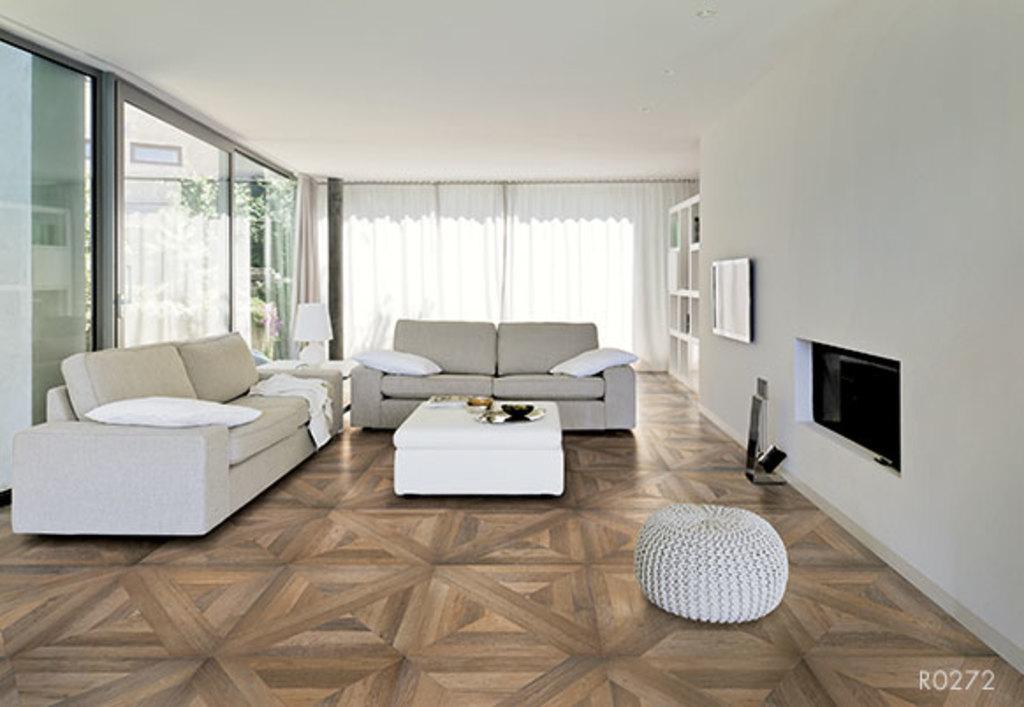Could you give a brief overview of what you see in this image? The image is taken in the room. In the center of the image there is a sofa and there is a stand placed before it. On the right there is a tv attached to the wall. on the left there are doors. In the background there is a curtain and we can also see a couch. 